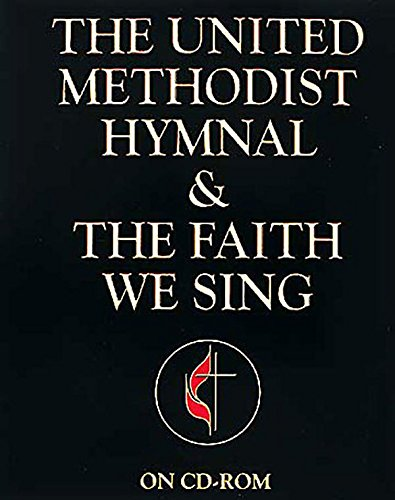Is this christianity book? Yes, it is indeed a Christian book, focusing on hymns and spiritual worship, as indicated by the content and affiliations of 'The United Methodist Church.' 